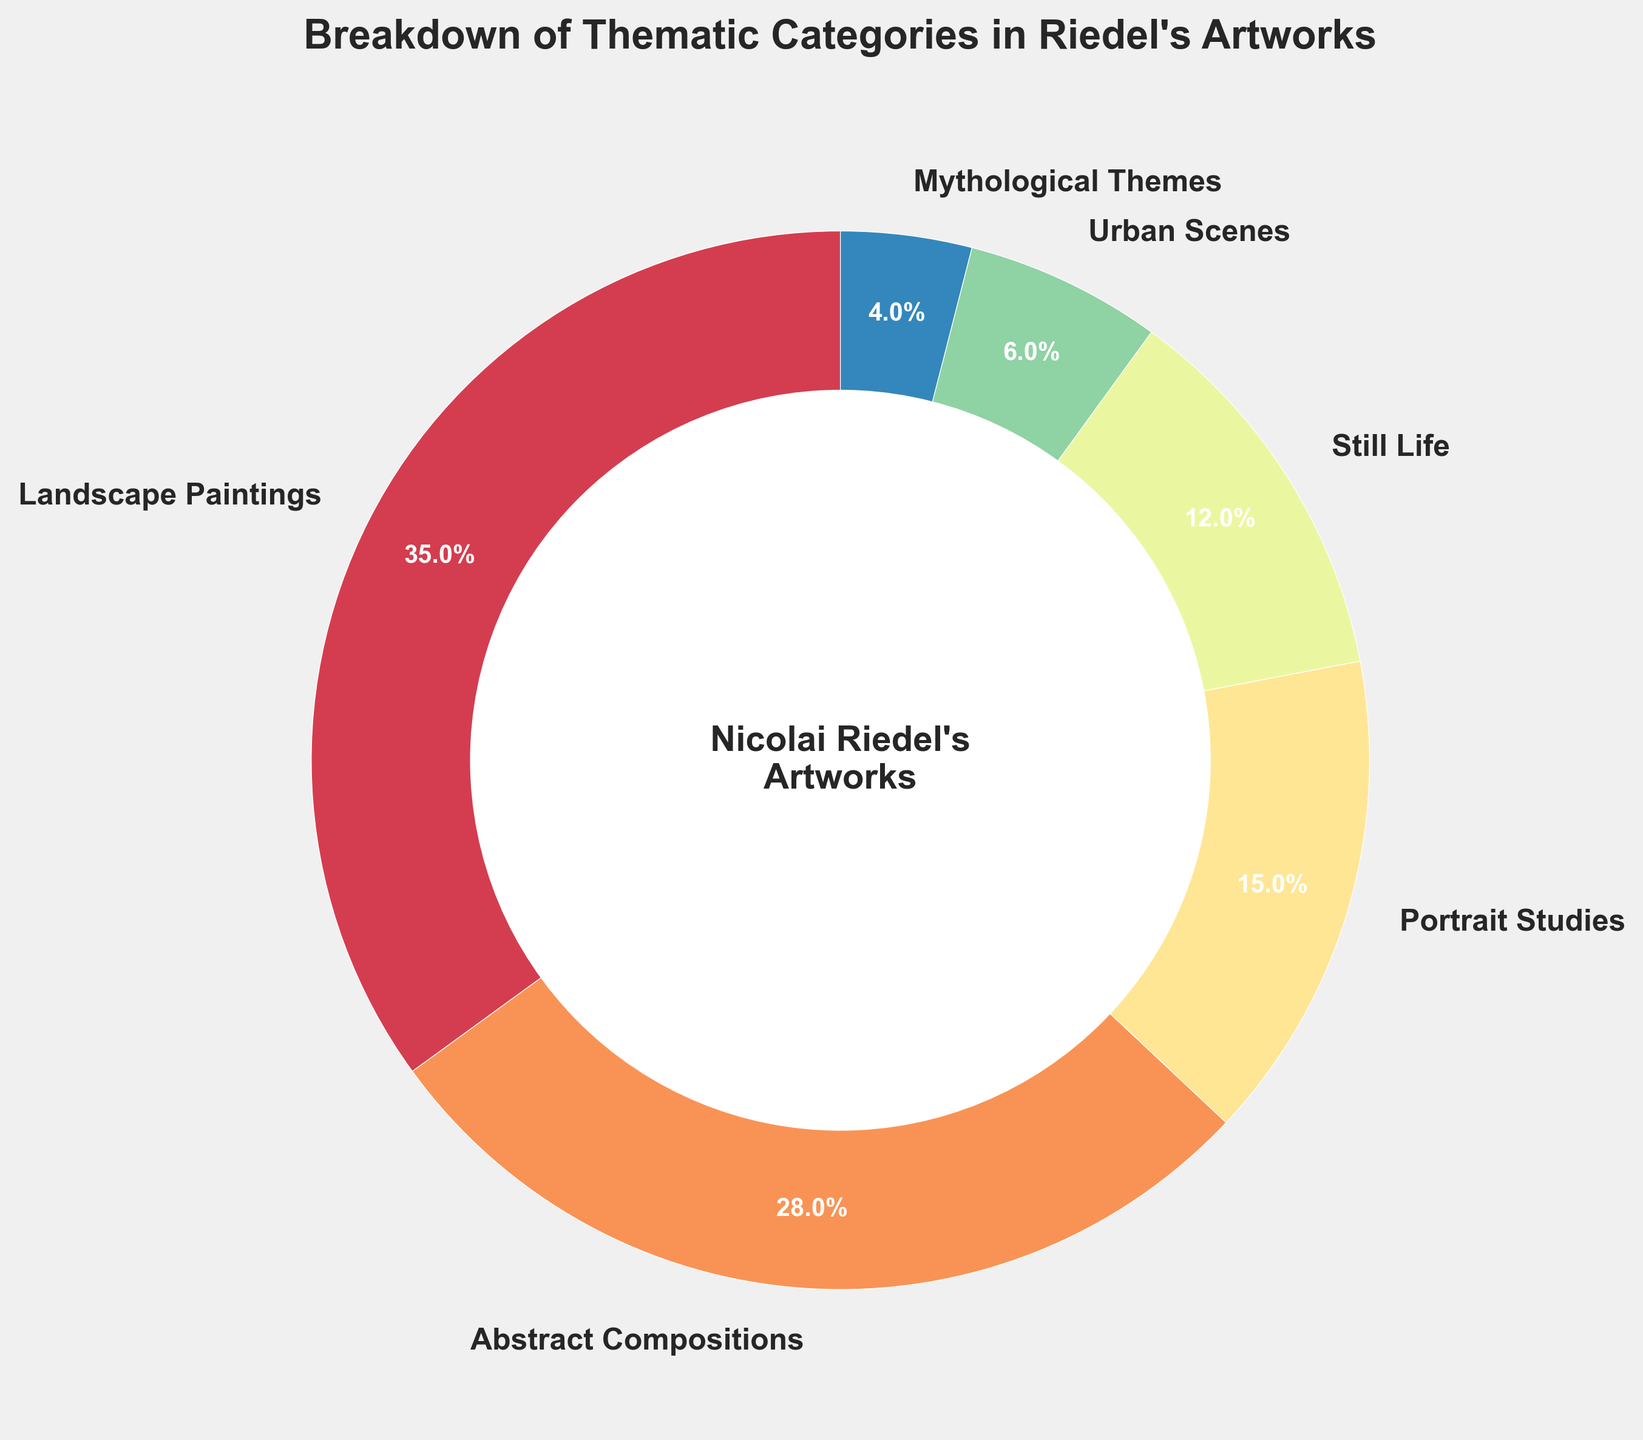What percentage of Nicolai Riedel's artworks is devoted to still life? From the breakdown of thematic categories, Still Life accounts for 12%.
Answer: 12% Which category has the highest percentage? By observing the chart, we see that Landscape Paintings has the highest percentage at 35%.
Answer: Landscape Paintings How do the percentages of Urban Scenes and Mythological Themes combined compare to the total percentage of Abstract Compositions? Urban Scenes account for 6% and Mythological Themes for 4%. Combining these, we get 6% + 4% = 10%, which is less than Abstract Compositions at 28%.
Answer: Less than What is the difference between the highest and lowest percentage categories? The highest percentage is from Landscape Paintings at 35%, and the lowest is from Mythological Themes at 4%. The difference is 35% - 4% = 31%.
Answer: 31% Arrange the categories in descending order of their percentages. Based on the chart, the categories in descending order are: Landscape Paintings (35%), Abstract Compositions (28%), Portrait Studies (15%), Still Life (12%), Urban Scenes (6%), and Mythological Themes (4%).
Answer: Landscape Paintings, Abstract Compositions, Portrait Studies, Still Life, Urban Scenes, Mythological Themes What is the combined percentage of Portrait Studies and Still Life? From the chart, Portrait Studies account for 15%, and Still Life for 12%. Combined, this is 15% + 12% = 27%.
Answer: 27% Which category has the closest percentage to Still Life? Still Life is at 12%. The closest percentage is Portrait Studies at 15%.
Answer: Portrait Studies What percentage of Nicolai Riedel's artworks are not Landscape Paintings? Since Landscape Paintings account for 35%, the remaining percentage is 100% - 35% = 65%.
Answer: 65% If the total number of artworks is 200, how many artworks fall under Abstract Compositions? If Abstract Compositions represent 28% of the total artworks: 0.28 * 200 = 56 artworks.
Answer: 56 What is the central text displayed within the pie chart? The central text in the pie chart reads "Nicolai Riedel's\nArtworks".
Answer: Nicolai Riedel's Artworks 